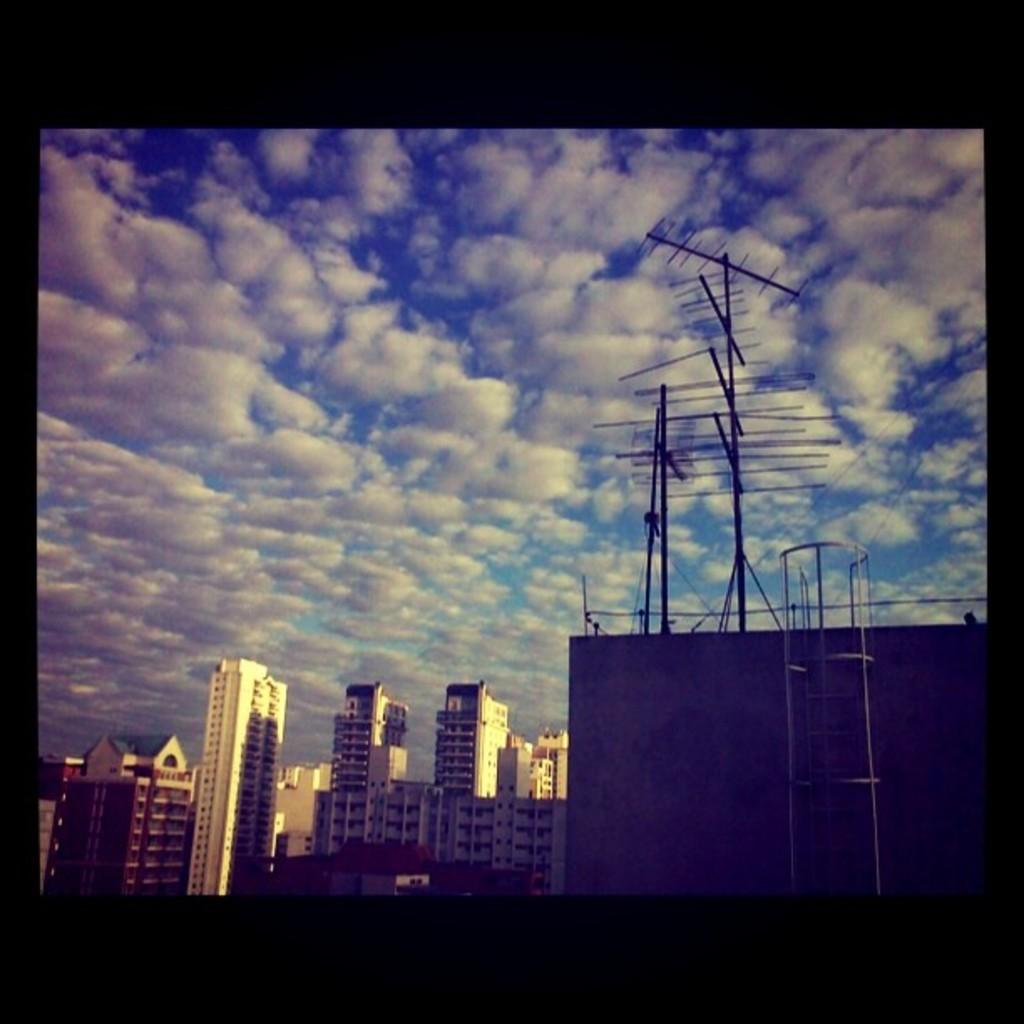What structures are located on the left side of the image? There are buildings on the left side of the image. What is visible at the top of the image? The sky is visible at the top of the image. What type of equipment can be seen on the right side of the image? There are antennas on the right side of the image. Where is the jail located in the image? There is no jail present in the image. What type of trail can be seen on the right side of the image? There is no trail present in the image; it features antennas instead. 